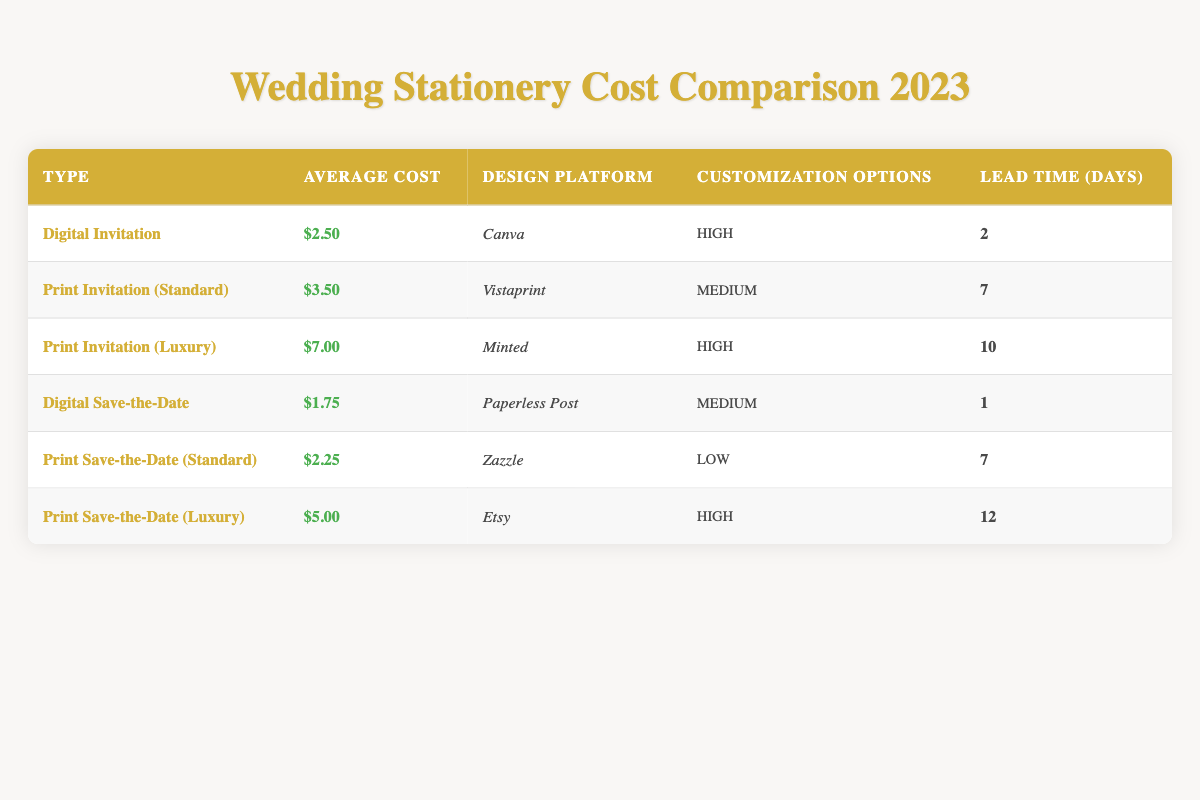What is the average cost of a Digital Invitation? The average cost for a Digital Invitation is listed directly in the table under the "Average Cost" column, and it shows $2.50.
Answer: $2.50 How much does a Print Invitation (Luxury) cost? The cost is provided in the table specifically for the Print Invitation (Luxury) row, which states the average cost as $7.00.
Answer: $7.00 Which design platform is used for Print Save-the-Date (Luxury)? Looking at the table, the design platform for the Print Save-the-Date (Luxury) is specified in the corresponding row, and it is Etsy.
Answer: Etsy Is the customization option for Digital Save-the-Date high? The table indicates the customization options for Digital Save-the-Date, which lists it as medium, so the statement is false.
Answer: No What is the lead time for Print Save-the-Date (Standard) invitations? The lead time is clearly stated in the table under the relevant row for Print Save-the-Date (Standard), which indicates it takes 7 days.
Answer: 7 days What is the average cost of print invitations compared to digital invitations? For Print Invitations (Standard), the cost is $3.50, and for Print Invitations (Luxury), it's $7.00. The average for print can be calculated as (3.50 + 7.00) / 2 = 5.25. For Digital Invitations, the cost is $2.50. Comparing both averages gives 5.25 for print and 2.50 for digital. Print costs are higher.
Answer: Print: $5.25, Digital: $2.50 What customization option is available for Print Save-the-Date (Standard)? The table provides this information directly, showing that the customization options for Print Save-the-Date (Standard) are low.
Answer: Low Which stationery type has the shortest lead time? By evaluating the lead time column in the table, it shows that Digital Save-the-Date has a lead time of 1 day, which is the shortest among the listed options.
Answer: 1 day What is the total average cost of all digital stationery types? Calculating the total average involves adding the costs of two digital items: Digital Invitation ($2.50) and Digital Save-the-Date ($1.75). The total cost is 2.50 + 1.75 = 4.25. With two items, the average is 4.25 / 2 = 2.125.
Answer: $2.13 